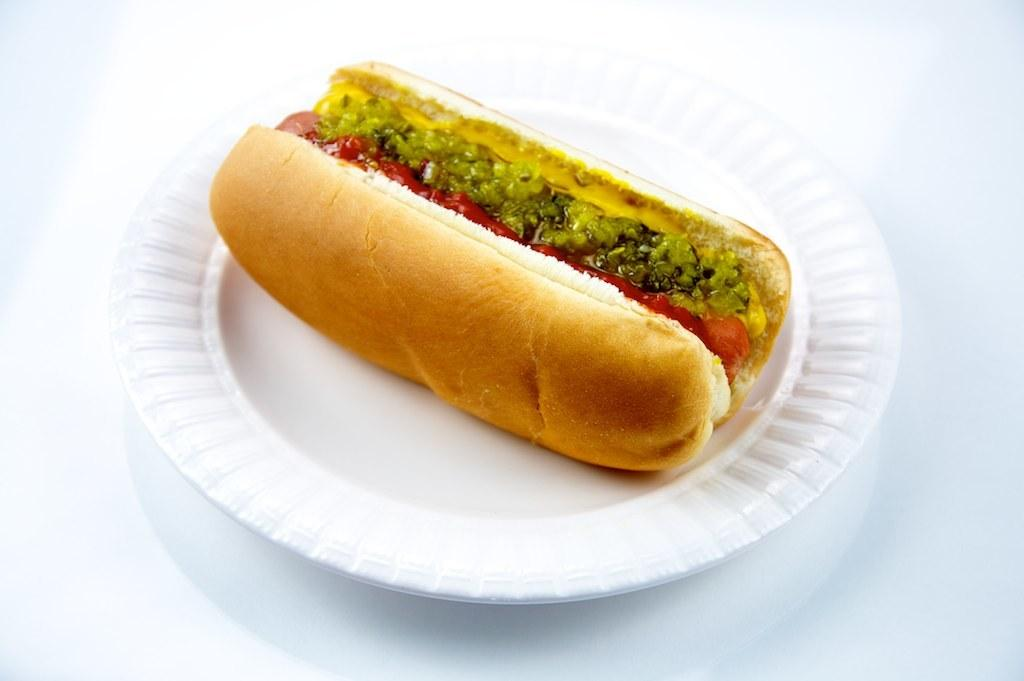What type of food is on the plate in the image? There is a burger on a white plate in the image. What is supporting the plate in the image? There is a table beneath the plate in the image. What type of sponge is being used to give a haircut in the image? There is no sponge or haircut present in the image; it only features a burger on a plate and a table beneath it. 